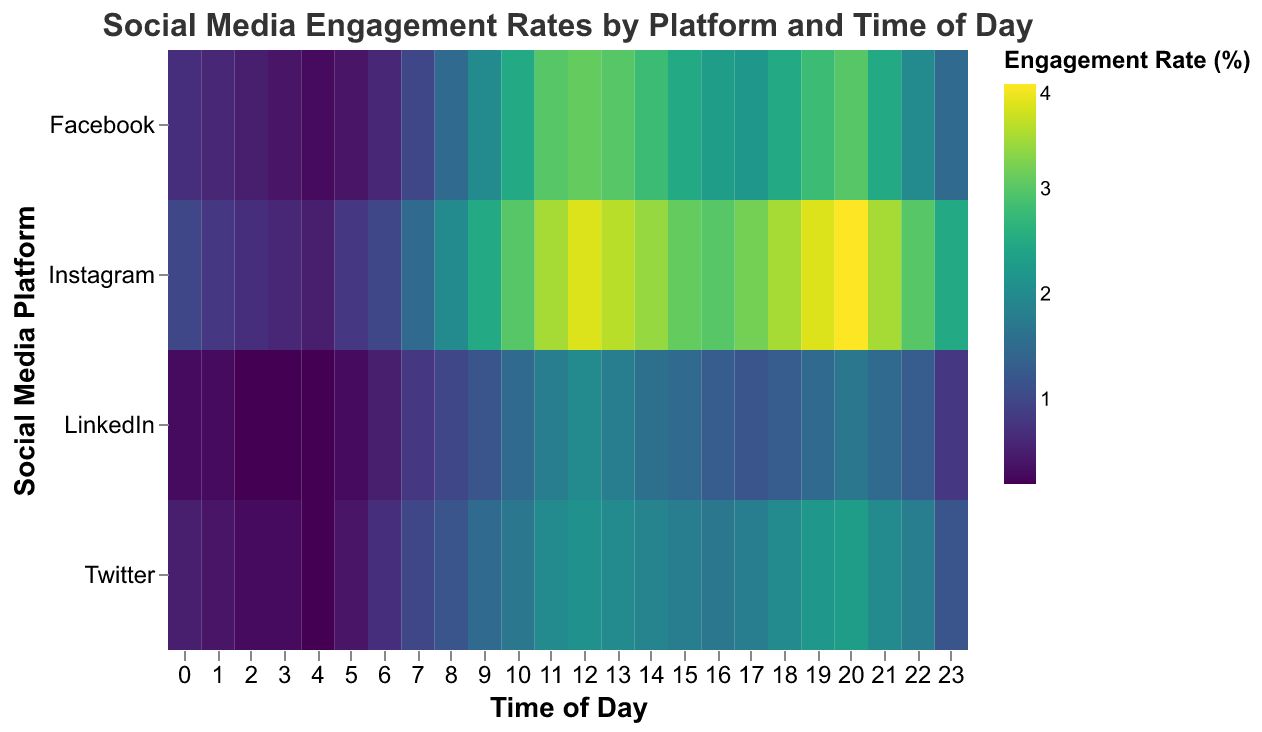What time of day does Facebook have the highest engagement rate? Look at the heatmap and identify the time period for Facebook with the darkest color, which represents the highest engagement rate. The highest engagement rate for Facebook occurs at the 12th hour of the day, with an engagement rate of 3.1%.
Answer: 12th hour Which platform shows the highest engagement rate overall? To find the platform with the highest engagement rate, check all the platforms provided and identify the one with the darkest color. The highest overall engagement rate is for Instagram at the 20th hour, which is 4.0%.
Answer: Instagram At what time does LinkedIn have the lowest engagement rate, and what is it? Look at the color scale for LinkedIn to find the time with the lightest color. LinkedIn has the lowest engagement rate at the 2nd, 3rd, and 4th hours, all with a rate of 0.2%.
Answer: 2nd, 3rd, and 4th hours, 0.2% How does the engagement rate on Twitter compare between 9 AM and 9 PM? Refer to the heatmap to find the engagement rates for Twitter at 9 AM and 9 PM. At 9 AM the rate is 1.5%, and at 9 PM the rate is 2.2%, which is higher in the evening compared to the morning.
Answer: Higher at 9 PM During which hour does Instagram generally outperform Facebook in terms of engagement rate? Compare the shades of color in the heatmap for both Facebook and Instagram for each hour. Instagram generally outperforms Facebook during the 20th hour, where Instagram has a rate of 4.0% compared to Facebook's 3.0%.
Answer: 20th hour Which platform has the steadiest engagement rate throughout the day? Look at the heatmap and compare the color distribution within each platform. LinkedIn shows a steadier engagement rate throughout the day as the shades are more consistent, lacking extreme highs or lows.
Answer: LinkedIn What is the average engagement rate for Twitter at 8 AM? Refer to the heatmap and find the engagement rate for Twitter at 8 AM, which is 1.2%.
Answer: 1.2% Does Facebook's engagement rate show any particular trend in the evening hours? Assess the pattern of colors from 6 PM to 11 PM on the Facebook row. There is an increase in engagement rate until 8 PM, with a high at 3.0%, and then it shows a decreasing trend towards 11 PM.
Answer: Increasing then decreasing 